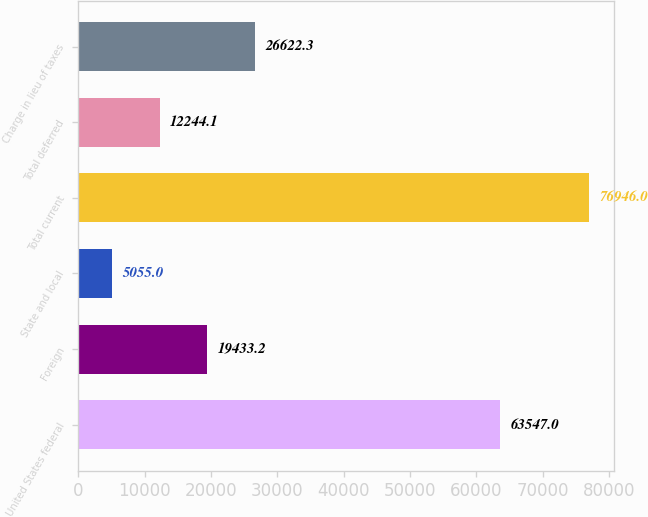Convert chart to OTSL. <chart><loc_0><loc_0><loc_500><loc_500><bar_chart><fcel>United States federal<fcel>Foreign<fcel>State and local<fcel>Total current<fcel>Total deferred<fcel>Charge in lieu of taxes<nl><fcel>63547<fcel>19433.2<fcel>5055<fcel>76946<fcel>12244.1<fcel>26622.3<nl></chart> 